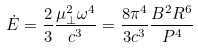Convert formula to latex. <formula><loc_0><loc_0><loc_500><loc_500>\dot { E } = \frac { 2 } { 3 } \frac { \mu ^ { 2 } _ { \perp } \omega ^ { 4 } } { c ^ { 3 } } = \frac { 8 \pi ^ { 4 } } { 3 c ^ { 3 } } \frac { B ^ { 2 } R ^ { 6 } } { P ^ { 4 } }</formula> 